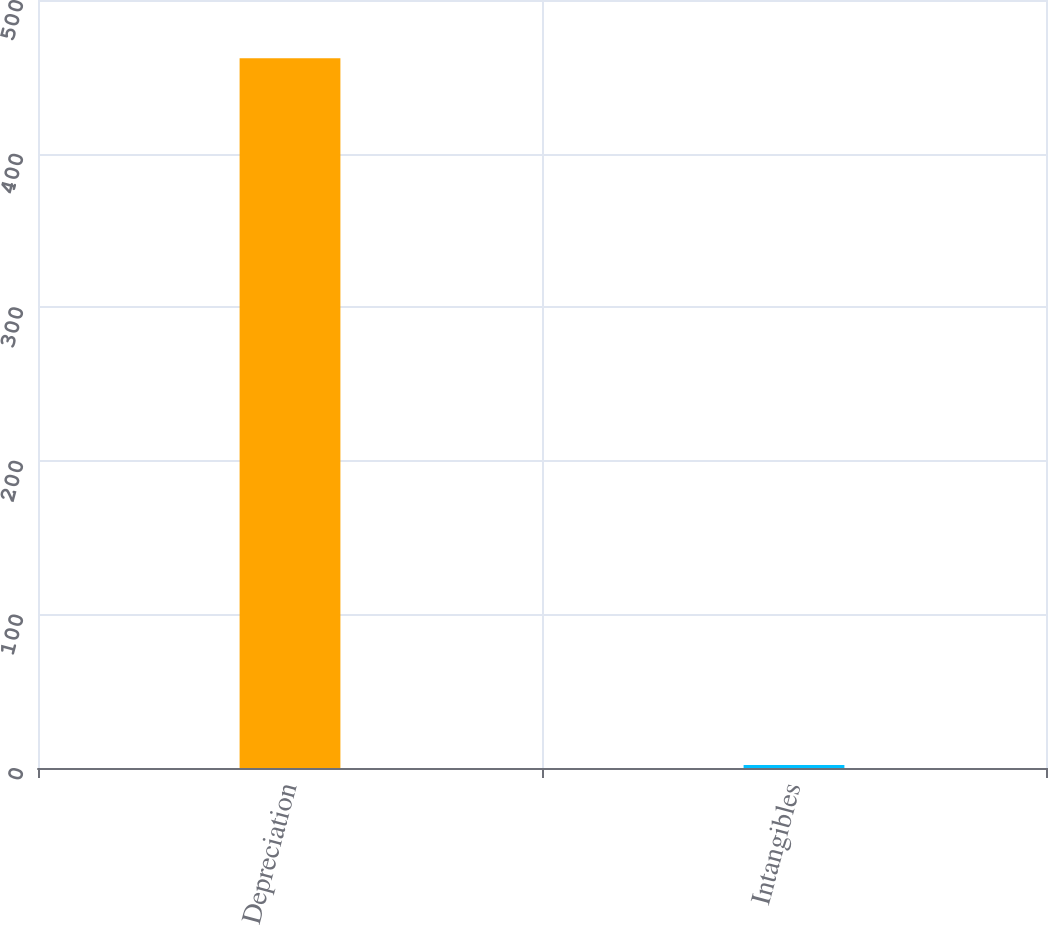Convert chart. <chart><loc_0><loc_0><loc_500><loc_500><bar_chart><fcel>Depreciation<fcel>Intangibles<nl><fcel>462<fcel>2<nl></chart> 